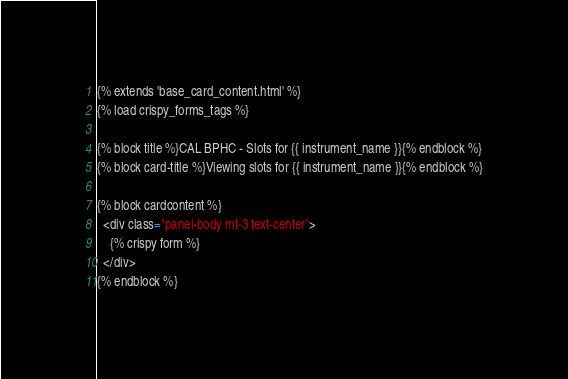Convert code to text. <code><loc_0><loc_0><loc_500><loc_500><_HTML_>{% extends 'base_card_content.html' %}
{% load crispy_forms_tags %}

{% block title %}CAL BPHC - Slots for {{ instrument_name }}{% endblock %}
{% block card-title %}Viewing slots for {{ instrument_name }}{% endblock %}

{% block cardcontent %}
  <div class="panel-body mt-3 text-center">
    {% crispy form %}
  </div>
{% endblock %}
</code> 